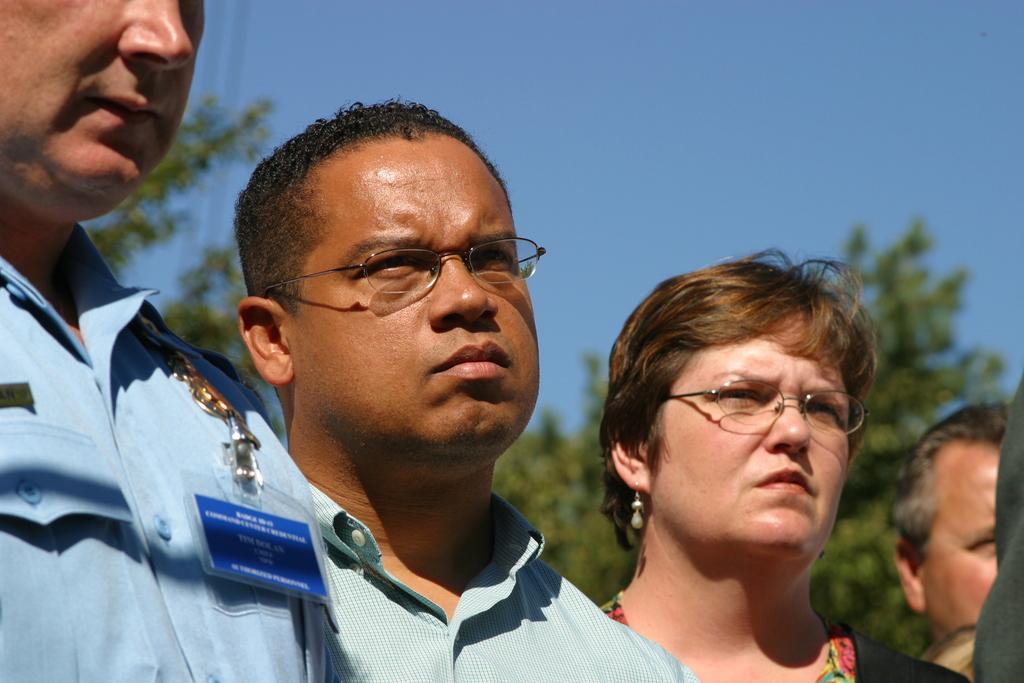Describe this image in one or two sentences. In the foreground of the picture there are people standing. The background is blurred. In the background there are trees and cables. Sky is clear and it is sunny. 